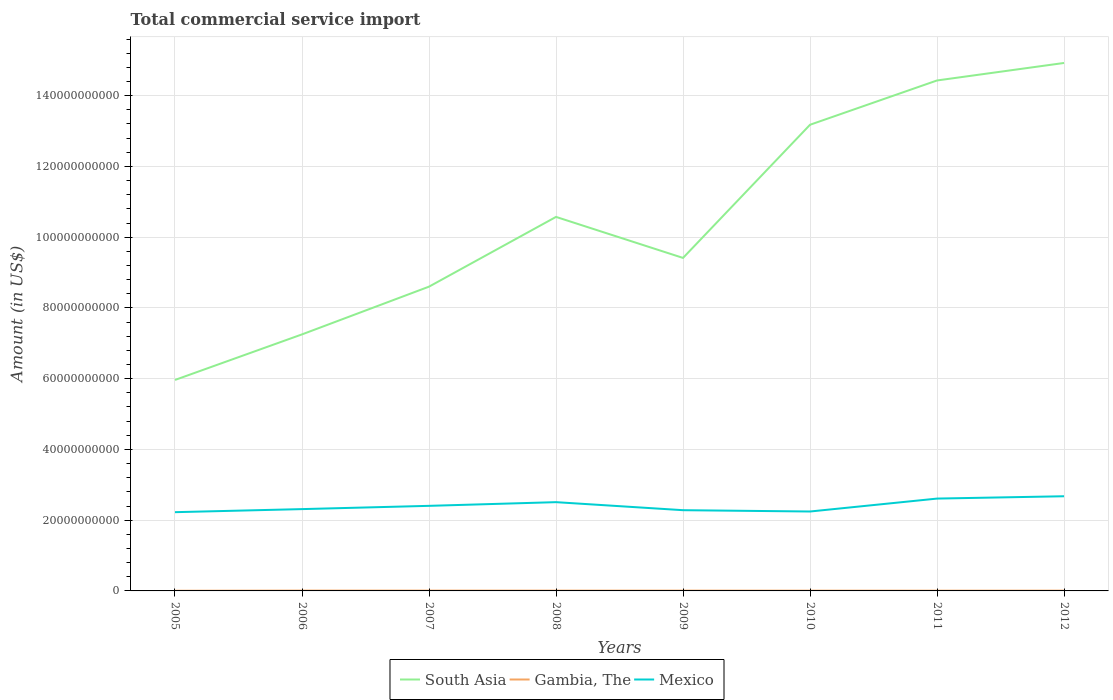Does the line corresponding to Gambia, The intersect with the line corresponding to South Asia?
Your response must be concise. No. Is the number of lines equal to the number of legend labels?
Ensure brevity in your answer.  Yes. Across all years, what is the maximum total commercial service import in Mexico?
Your answer should be compact. 2.23e+1. In which year was the total commercial service import in South Asia maximum?
Keep it short and to the point. 2005. What is the total total commercial service import in Gambia, The in the graph?
Provide a succinct answer. 4.19e+06. What is the difference between the highest and the second highest total commercial service import in Gambia, The?
Make the answer very short. 4.72e+07. What is the difference between the highest and the lowest total commercial service import in Mexico?
Keep it short and to the point. 3. Is the total commercial service import in Mexico strictly greater than the total commercial service import in South Asia over the years?
Your answer should be compact. Yes. How many years are there in the graph?
Your response must be concise. 8. What is the difference between two consecutive major ticks on the Y-axis?
Provide a short and direct response. 2.00e+1. Are the values on the major ticks of Y-axis written in scientific E-notation?
Offer a terse response. No. Where does the legend appear in the graph?
Provide a short and direct response. Bottom center. How are the legend labels stacked?
Keep it short and to the point. Horizontal. What is the title of the graph?
Your answer should be very brief. Total commercial service import. What is the label or title of the Y-axis?
Your response must be concise. Amount (in US$). What is the Amount (in US$) of South Asia in 2005?
Make the answer very short. 5.96e+1. What is the Amount (in US$) of Gambia, The in 2005?
Your answer should be compact. 4.69e+07. What is the Amount (in US$) of Mexico in 2005?
Make the answer very short. 2.23e+1. What is the Amount (in US$) of South Asia in 2006?
Provide a succinct answer. 7.25e+1. What is the Amount (in US$) of Gambia, The in 2006?
Your answer should be very brief. 9.41e+07. What is the Amount (in US$) in Mexico in 2006?
Provide a short and direct response. 2.31e+1. What is the Amount (in US$) in South Asia in 2007?
Ensure brevity in your answer.  8.60e+1. What is the Amount (in US$) of Gambia, The in 2007?
Provide a succinct answer. 8.68e+07. What is the Amount (in US$) of Mexico in 2007?
Ensure brevity in your answer.  2.41e+1. What is the Amount (in US$) of South Asia in 2008?
Your answer should be very brief. 1.06e+11. What is the Amount (in US$) in Gambia, The in 2008?
Your response must be concise. 8.56e+07. What is the Amount (in US$) of Mexico in 2008?
Offer a very short reply. 2.51e+1. What is the Amount (in US$) in South Asia in 2009?
Offer a terse response. 9.41e+1. What is the Amount (in US$) in Gambia, The in 2009?
Your response must be concise. 8.26e+07. What is the Amount (in US$) of Mexico in 2009?
Your response must be concise. 2.28e+1. What is the Amount (in US$) in South Asia in 2010?
Your answer should be compact. 1.32e+11. What is the Amount (in US$) of Gambia, The in 2010?
Keep it short and to the point. 7.32e+07. What is the Amount (in US$) of Mexico in 2010?
Offer a terse response. 2.25e+1. What is the Amount (in US$) of South Asia in 2011?
Provide a short and direct response. 1.44e+11. What is the Amount (in US$) in Gambia, The in 2011?
Keep it short and to the point. 6.84e+07. What is the Amount (in US$) in Mexico in 2011?
Offer a very short reply. 2.61e+1. What is the Amount (in US$) of South Asia in 2012?
Your response must be concise. 1.49e+11. What is the Amount (in US$) in Gambia, The in 2012?
Provide a succinct answer. 8.03e+07. What is the Amount (in US$) in Mexico in 2012?
Offer a very short reply. 2.68e+1. Across all years, what is the maximum Amount (in US$) of South Asia?
Provide a succinct answer. 1.49e+11. Across all years, what is the maximum Amount (in US$) in Gambia, The?
Your answer should be compact. 9.41e+07. Across all years, what is the maximum Amount (in US$) of Mexico?
Give a very brief answer. 2.68e+1. Across all years, what is the minimum Amount (in US$) of South Asia?
Provide a short and direct response. 5.96e+1. Across all years, what is the minimum Amount (in US$) of Gambia, The?
Ensure brevity in your answer.  4.69e+07. Across all years, what is the minimum Amount (in US$) in Mexico?
Keep it short and to the point. 2.23e+1. What is the total Amount (in US$) of South Asia in the graph?
Your answer should be compact. 8.43e+11. What is the total Amount (in US$) in Gambia, The in the graph?
Provide a short and direct response. 6.18e+08. What is the total Amount (in US$) of Mexico in the graph?
Make the answer very short. 1.93e+11. What is the difference between the Amount (in US$) in South Asia in 2005 and that in 2006?
Offer a very short reply. -1.29e+1. What is the difference between the Amount (in US$) of Gambia, The in 2005 and that in 2006?
Keep it short and to the point. -4.72e+07. What is the difference between the Amount (in US$) of Mexico in 2005 and that in 2006?
Your answer should be very brief. -8.67e+08. What is the difference between the Amount (in US$) of South Asia in 2005 and that in 2007?
Your response must be concise. -2.64e+1. What is the difference between the Amount (in US$) in Gambia, The in 2005 and that in 2007?
Offer a very short reply. -3.99e+07. What is the difference between the Amount (in US$) in Mexico in 2005 and that in 2007?
Your answer should be very brief. -1.79e+09. What is the difference between the Amount (in US$) in South Asia in 2005 and that in 2008?
Make the answer very short. -4.61e+1. What is the difference between the Amount (in US$) in Gambia, The in 2005 and that in 2008?
Give a very brief answer. -3.88e+07. What is the difference between the Amount (in US$) in Mexico in 2005 and that in 2008?
Provide a short and direct response. -2.83e+09. What is the difference between the Amount (in US$) in South Asia in 2005 and that in 2009?
Offer a terse response. -3.45e+1. What is the difference between the Amount (in US$) in Gambia, The in 2005 and that in 2009?
Your response must be concise. -3.57e+07. What is the difference between the Amount (in US$) in Mexico in 2005 and that in 2009?
Your answer should be compact. -5.61e+08. What is the difference between the Amount (in US$) of South Asia in 2005 and that in 2010?
Your answer should be very brief. -7.21e+1. What is the difference between the Amount (in US$) of Gambia, The in 2005 and that in 2010?
Make the answer very short. -2.63e+07. What is the difference between the Amount (in US$) in Mexico in 2005 and that in 2010?
Keep it short and to the point. -1.89e+08. What is the difference between the Amount (in US$) in South Asia in 2005 and that in 2011?
Give a very brief answer. -8.47e+1. What is the difference between the Amount (in US$) in Gambia, The in 2005 and that in 2011?
Your response must be concise. -2.15e+07. What is the difference between the Amount (in US$) of Mexico in 2005 and that in 2011?
Offer a very short reply. -3.84e+09. What is the difference between the Amount (in US$) in South Asia in 2005 and that in 2012?
Keep it short and to the point. -8.96e+1. What is the difference between the Amount (in US$) in Gambia, The in 2005 and that in 2012?
Make the answer very short. -3.34e+07. What is the difference between the Amount (in US$) in Mexico in 2005 and that in 2012?
Your answer should be very brief. -4.50e+09. What is the difference between the Amount (in US$) in South Asia in 2006 and that in 2007?
Make the answer very short. -1.35e+1. What is the difference between the Amount (in US$) in Gambia, The in 2006 and that in 2007?
Ensure brevity in your answer.  7.33e+06. What is the difference between the Amount (in US$) of Mexico in 2006 and that in 2007?
Your answer should be compact. -9.23e+08. What is the difference between the Amount (in US$) of South Asia in 2006 and that in 2008?
Make the answer very short. -3.32e+1. What is the difference between the Amount (in US$) of Gambia, The in 2006 and that in 2008?
Provide a succinct answer. 8.43e+06. What is the difference between the Amount (in US$) of Mexico in 2006 and that in 2008?
Keep it short and to the point. -1.96e+09. What is the difference between the Amount (in US$) in South Asia in 2006 and that in 2009?
Make the answer very short. -2.16e+1. What is the difference between the Amount (in US$) in Gambia, The in 2006 and that in 2009?
Your answer should be very brief. 1.15e+07. What is the difference between the Amount (in US$) in Mexico in 2006 and that in 2009?
Make the answer very short. 3.06e+08. What is the difference between the Amount (in US$) in South Asia in 2006 and that in 2010?
Ensure brevity in your answer.  -5.93e+1. What is the difference between the Amount (in US$) in Gambia, The in 2006 and that in 2010?
Keep it short and to the point. 2.09e+07. What is the difference between the Amount (in US$) in Mexico in 2006 and that in 2010?
Make the answer very short. 6.78e+08. What is the difference between the Amount (in US$) of South Asia in 2006 and that in 2011?
Keep it short and to the point. -7.18e+1. What is the difference between the Amount (in US$) in Gambia, The in 2006 and that in 2011?
Give a very brief answer. 2.57e+07. What is the difference between the Amount (in US$) in Mexico in 2006 and that in 2011?
Offer a very short reply. -2.98e+09. What is the difference between the Amount (in US$) of South Asia in 2006 and that in 2012?
Your answer should be very brief. -7.67e+1. What is the difference between the Amount (in US$) of Gambia, The in 2006 and that in 2012?
Give a very brief answer. 1.38e+07. What is the difference between the Amount (in US$) in Mexico in 2006 and that in 2012?
Ensure brevity in your answer.  -3.63e+09. What is the difference between the Amount (in US$) in South Asia in 2007 and that in 2008?
Your response must be concise. -1.97e+1. What is the difference between the Amount (in US$) in Gambia, The in 2007 and that in 2008?
Make the answer very short. 1.10e+06. What is the difference between the Amount (in US$) of Mexico in 2007 and that in 2008?
Make the answer very short. -1.04e+09. What is the difference between the Amount (in US$) in South Asia in 2007 and that in 2009?
Your answer should be compact. -8.12e+09. What is the difference between the Amount (in US$) of Gambia, The in 2007 and that in 2009?
Keep it short and to the point. 4.19e+06. What is the difference between the Amount (in US$) of Mexico in 2007 and that in 2009?
Give a very brief answer. 1.23e+09. What is the difference between the Amount (in US$) in South Asia in 2007 and that in 2010?
Offer a very short reply. -4.58e+1. What is the difference between the Amount (in US$) of Gambia, The in 2007 and that in 2010?
Your response must be concise. 1.36e+07. What is the difference between the Amount (in US$) in Mexico in 2007 and that in 2010?
Keep it short and to the point. 1.60e+09. What is the difference between the Amount (in US$) of South Asia in 2007 and that in 2011?
Your answer should be very brief. -5.83e+1. What is the difference between the Amount (in US$) in Gambia, The in 2007 and that in 2011?
Make the answer very short. 1.83e+07. What is the difference between the Amount (in US$) in Mexico in 2007 and that in 2011?
Your answer should be very brief. -2.05e+09. What is the difference between the Amount (in US$) in South Asia in 2007 and that in 2012?
Offer a terse response. -6.32e+1. What is the difference between the Amount (in US$) of Gambia, The in 2007 and that in 2012?
Offer a very short reply. 6.48e+06. What is the difference between the Amount (in US$) of Mexico in 2007 and that in 2012?
Offer a very short reply. -2.71e+09. What is the difference between the Amount (in US$) in South Asia in 2008 and that in 2009?
Keep it short and to the point. 1.16e+1. What is the difference between the Amount (in US$) in Gambia, The in 2008 and that in 2009?
Keep it short and to the point. 3.08e+06. What is the difference between the Amount (in US$) in Mexico in 2008 and that in 2009?
Provide a succinct answer. 2.27e+09. What is the difference between the Amount (in US$) in South Asia in 2008 and that in 2010?
Your answer should be compact. -2.61e+1. What is the difference between the Amount (in US$) of Gambia, The in 2008 and that in 2010?
Ensure brevity in your answer.  1.25e+07. What is the difference between the Amount (in US$) in Mexico in 2008 and that in 2010?
Give a very brief answer. 2.64e+09. What is the difference between the Amount (in US$) of South Asia in 2008 and that in 2011?
Your answer should be very brief. -3.86e+1. What is the difference between the Amount (in US$) in Gambia, The in 2008 and that in 2011?
Give a very brief answer. 1.72e+07. What is the difference between the Amount (in US$) of Mexico in 2008 and that in 2011?
Provide a short and direct response. -1.01e+09. What is the difference between the Amount (in US$) of South Asia in 2008 and that in 2012?
Offer a very short reply. -4.35e+1. What is the difference between the Amount (in US$) of Gambia, The in 2008 and that in 2012?
Provide a succinct answer. 5.38e+06. What is the difference between the Amount (in US$) in Mexico in 2008 and that in 2012?
Give a very brief answer. -1.67e+09. What is the difference between the Amount (in US$) of South Asia in 2009 and that in 2010?
Provide a short and direct response. -3.76e+1. What is the difference between the Amount (in US$) in Gambia, The in 2009 and that in 2010?
Provide a succinct answer. 9.39e+06. What is the difference between the Amount (in US$) in Mexico in 2009 and that in 2010?
Offer a very short reply. 3.72e+08. What is the difference between the Amount (in US$) of South Asia in 2009 and that in 2011?
Provide a short and direct response. -5.02e+1. What is the difference between the Amount (in US$) of Gambia, The in 2009 and that in 2011?
Provide a succinct answer. 1.42e+07. What is the difference between the Amount (in US$) in Mexico in 2009 and that in 2011?
Make the answer very short. -3.28e+09. What is the difference between the Amount (in US$) of South Asia in 2009 and that in 2012?
Offer a very short reply. -5.51e+1. What is the difference between the Amount (in US$) of Gambia, The in 2009 and that in 2012?
Offer a very short reply. 2.30e+06. What is the difference between the Amount (in US$) in Mexico in 2009 and that in 2012?
Keep it short and to the point. -3.94e+09. What is the difference between the Amount (in US$) of South Asia in 2010 and that in 2011?
Keep it short and to the point. -1.25e+1. What is the difference between the Amount (in US$) of Gambia, The in 2010 and that in 2011?
Give a very brief answer. 4.77e+06. What is the difference between the Amount (in US$) in Mexico in 2010 and that in 2011?
Ensure brevity in your answer.  -3.65e+09. What is the difference between the Amount (in US$) of South Asia in 2010 and that in 2012?
Provide a succinct answer. -1.75e+1. What is the difference between the Amount (in US$) of Gambia, The in 2010 and that in 2012?
Your response must be concise. -7.09e+06. What is the difference between the Amount (in US$) of Mexico in 2010 and that in 2012?
Offer a terse response. -4.31e+09. What is the difference between the Amount (in US$) of South Asia in 2011 and that in 2012?
Your response must be concise. -4.95e+09. What is the difference between the Amount (in US$) of Gambia, The in 2011 and that in 2012?
Offer a very short reply. -1.19e+07. What is the difference between the Amount (in US$) in Mexico in 2011 and that in 2012?
Give a very brief answer. -6.57e+08. What is the difference between the Amount (in US$) of South Asia in 2005 and the Amount (in US$) of Gambia, The in 2006?
Offer a terse response. 5.95e+1. What is the difference between the Amount (in US$) in South Asia in 2005 and the Amount (in US$) in Mexico in 2006?
Provide a succinct answer. 3.65e+1. What is the difference between the Amount (in US$) in Gambia, The in 2005 and the Amount (in US$) in Mexico in 2006?
Give a very brief answer. -2.31e+1. What is the difference between the Amount (in US$) of South Asia in 2005 and the Amount (in US$) of Gambia, The in 2007?
Your answer should be compact. 5.96e+1. What is the difference between the Amount (in US$) in South Asia in 2005 and the Amount (in US$) in Mexico in 2007?
Keep it short and to the point. 3.56e+1. What is the difference between the Amount (in US$) in Gambia, The in 2005 and the Amount (in US$) in Mexico in 2007?
Your response must be concise. -2.40e+1. What is the difference between the Amount (in US$) in South Asia in 2005 and the Amount (in US$) in Gambia, The in 2008?
Offer a very short reply. 5.96e+1. What is the difference between the Amount (in US$) in South Asia in 2005 and the Amount (in US$) in Mexico in 2008?
Make the answer very short. 3.45e+1. What is the difference between the Amount (in US$) of Gambia, The in 2005 and the Amount (in US$) of Mexico in 2008?
Your response must be concise. -2.50e+1. What is the difference between the Amount (in US$) in South Asia in 2005 and the Amount (in US$) in Gambia, The in 2009?
Offer a very short reply. 5.96e+1. What is the difference between the Amount (in US$) in South Asia in 2005 and the Amount (in US$) in Mexico in 2009?
Your answer should be compact. 3.68e+1. What is the difference between the Amount (in US$) of Gambia, The in 2005 and the Amount (in US$) of Mexico in 2009?
Give a very brief answer. -2.28e+1. What is the difference between the Amount (in US$) in South Asia in 2005 and the Amount (in US$) in Gambia, The in 2010?
Offer a terse response. 5.96e+1. What is the difference between the Amount (in US$) in South Asia in 2005 and the Amount (in US$) in Mexico in 2010?
Offer a very short reply. 3.72e+1. What is the difference between the Amount (in US$) in Gambia, The in 2005 and the Amount (in US$) in Mexico in 2010?
Keep it short and to the point. -2.24e+1. What is the difference between the Amount (in US$) of South Asia in 2005 and the Amount (in US$) of Gambia, The in 2011?
Offer a very short reply. 5.96e+1. What is the difference between the Amount (in US$) of South Asia in 2005 and the Amount (in US$) of Mexico in 2011?
Provide a short and direct response. 3.35e+1. What is the difference between the Amount (in US$) in Gambia, The in 2005 and the Amount (in US$) in Mexico in 2011?
Offer a very short reply. -2.61e+1. What is the difference between the Amount (in US$) of South Asia in 2005 and the Amount (in US$) of Gambia, The in 2012?
Your answer should be compact. 5.96e+1. What is the difference between the Amount (in US$) in South Asia in 2005 and the Amount (in US$) in Mexico in 2012?
Provide a short and direct response. 3.29e+1. What is the difference between the Amount (in US$) of Gambia, The in 2005 and the Amount (in US$) of Mexico in 2012?
Provide a short and direct response. -2.67e+1. What is the difference between the Amount (in US$) of South Asia in 2006 and the Amount (in US$) of Gambia, The in 2007?
Your answer should be compact. 7.24e+1. What is the difference between the Amount (in US$) of South Asia in 2006 and the Amount (in US$) of Mexico in 2007?
Give a very brief answer. 4.85e+1. What is the difference between the Amount (in US$) in Gambia, The in 2006 and the Amount (in US$) in Mexico in 2007?
Ensure brevity in your answer.  -2.40e+1. What is the difference between the Amount (in US$) of South Asia in 2006 and the Amount (in US$) of Gambia, The in 2008?
Provide a short and direct response. 7.24e+1. What is the difference between the Amount (in US$) of South Asia in 2006 and the Amount (in US$) of Mexico in 2008?
Offer a terse response. 4.74e+1. What is the difference between the Amount (in US$) of Gambia, The in 2006 and the Amount (in US$) of Mexico in 2008?
Provide a succinct answer. -2.50e+1. What is the difference between the Amount (in US$) of South Asia in 2006 and the Amount (in US$) of Gambia, The in 2009?
Make the answer very short. 7.24e+1. What is the difference between the Amount (in US$) in South Asia in 2006 and the Amount (in US$) in Mexico in 2009?
Provide a short and direct response. 4.97e+1. What is the difference between the Amount (in US$) in Gambia, The in 2006 and the Amount (in US$) in Mexico in 2009?
Offer a very short reply. -2.27e+1. What is the difference between the Amount (in US$) of South Asia in 2006 and the Amount (in US$) of Gambia, The in 2010?
Provide a succinct answer. 7.24e+1. What is the difference between the Amount (in US$) in South Asia in 2006 and the Amount (in US$) in Mexico in 2010?
Your response must be concise. 5.01e+1. What is the difference between the Amount (in US$) in Gambia, The in 2006 and the Amount (in US$) in Mexico in 2010?
Offer a terse response. -2.24e+1. What is the difference between the Amount (in US$) in South Asia in 2006 and the Amount (in US$) in Gambia, The in 2011?
Your answer should be compact. 7.24e+1. What is the difference between the Amount (in US$) of South Asia in 2006 and the Amount (in US$) of Mexico in 2011?
Your answer should be compact. 4.64e+1. What is the difference between the Amount (in US$) of Gambia, The in 2006 and the Amount (in US$) of Mexico in 2011?
Provide a short and direct response. -2.60e+1. What is the difference between the Amount (in US$) in South Asia in 2006 and the Amount (in US$) in Gambia, The in 2012?
Keep it short and to the point. 7.24e+1. What is the difference between the Amount (in US$) in South Asia in 2006 and the Amount (in US$) in Mexico in 2012?
Your response must be concise. 4.58e+1. What is the difference between the Amount (in US$) of Gambia, The in 2006 and the Amount (in US$) of Mexico in 2012?
Provide a succinct answer. -2.67e+1. What is the difference between the Amount (in US$) of South Asia in 2007 and the Amount (in US$) of Gambia, The in 2008?
Your answer should be compact. 8.59e+1. What is the difference between the Amount (in US$) of South Asia in 2007 and the Amount (in US$) of Mexico in 2008?
Your answer should be very brief. 6.09e+1. What is the difference between the Amount (in US$) of Gambia, The in 2007 and the Amount (in US$) of Mexico in 2008?
Ensure brevity in your answer.  -2.50e+1. What is the difference between the Amount (in US$) of South Asia in 2007 and the Amount (in US$) of Gambia, The in 2009?
Make the answer very short. 8.59e+1. What is the difference between the Amount (in US$) in South Asia in 2007 and the Amount (in US$) in Mexico in 2009?
Your answer should be very brief. 6.32e+1. What is the difference between the Amount (in US$) in Gambia, The in 2007 and the Amount (in US$) in Mexico in 2009?
Make the answer very short. -2.27e+1. What is the difference between the Amount (in US$) in South Asia in 2007 and the Amount (in US$) in Gambia, The in 2010?
Ensure brevity in your answer.  8.59e+1. What is the difference between the Amount (in US$) of South Asia in 2007 and the Amount (in US$) of Mexico in 2010?
Give a very brief answer. 6.36e+1. What is the difference between the Amount (in US$) in Gambia, The in 2007 and the Amount (in US$) in Mexico in 2010?
Your response must be concise. -2.24e+1. What is the difference between the Amount (in US$) of South Asia in 2007 and the Amount (in US$) of Gambia, The in 2011?
Your answer should be compact. 8.59e+1. What is the difference between the Amount (in US$) in South Asia in 2007 and the Amount (in US$) in Mexico in 2011?
Provide a short and direct response. 5.99e+1. What is the difference between the Amount (in US$) of Gambia, The in 2007 and the Amount (in US$) of Mexico in 2011?
Your answer should be compact. -2.60e+1. What is the difference between the Amount (in US$) of South Asia in 2007 and the Amount (in US$) of Gambia, The in 2012?
Your answer should be very brief. 8.59e+1. What is the difference between the Amount (in US$) in South Asia in 2007 and the Amount (in US$) in Mexico in 2012?
Offer a terse response. 5.93e+1. What is the difference between the Amount (in US$) in Gambia, The in 2007 and the Amount (in US$) in Mexico in 2012?
Your response must be concise. -2.67e+1. What is the difference between the Amount (in US$) of South Asia in 2008 and the Amount (in US$) of Gambia, The in 2009?
Your answer should be very brief. 1.06e+11. What is the difference between the Amount (in US$) in South Asia in 2008 and the Amount (in US$) in Mexico in 2009?
Make the answer very short. 8.29e+1. What is the difference between the Amount (in US$) in Gambia, The in 2008 and the Amount (in US$) in Mexico in 2009?
Offer a very short reply. -2.27e+1. What is the difference between the Amount (in US$) of South Asia in 2008 and the Amount (in US$) of Gambia, The in 2010?
Make the answer very short. 1.06e+11. What is the difference between the Amount (in US$) in South Asia in 2008 and the Amount (in US$) in Mexico in 2010?
Offer a terse response. 8.33e+1. What is the difference between the Amount (in US$) of Gambia, The in 2008 and the Amount (in US$) of Mexico in 2010?
Offer a very short reply. -2.24e+1. What is the difference between the Amount (in US$) in South Asia in 2008 and the Amount (in US$) in Gambia, The in 2011?
Your answer should be very brief. 1.06e+11. What is the difference between the Amount (in US$) in South Asia in 2008 and the Amount (in US$) in Mexico in 2011?
Provide a short and direct response. 7.96e+1. What is the difference between the Amount (in US$) of Gambia, The in 2008 and the Amount (in US$) of Mexico in 2011?
Ensure brevity in your answer.  -2.60e+1. What is the difference between the Amount (in US$) in South Asia in 2008 and the Amount (in US$) in Gambia, The in 2012?
Your answer should be very brief. 1.06e+11. What is the difference between the Amount (in US$) of South Asia in 2008 and the Amount (in US$) of Mexico in 2012?
Your response must be concise. 7.90e+1. What is the difference between the Amount (in US$) of Gambia, The in 2008 and the Amount (in US$) of Mexico in 2012?
Your answer should be very brief. -2.67e+1. What is the difference between the Amount (in US$) in South Asia in 2009 and the Amount (in US$) in Gambia, The in 2010?
Give a very brief answer. 9.41e+1. What is the difference between the Amount (in US$) in South Asia in 2009 and the Amount (in US$) in Mexico in 2010?
Offer a terse response. 7.17e+1. What is the difference between the Amount (in US$) in Gambia, The in 2009 and the Amount (in US$) in Mexico in 2010?
Offer a very short reply. -2.24e+1. What is the difference between the Amount (in US$) of South Asia in 2009 and the Amount (in US$) of Gambia, The in 2011?
Offer a very short reply. 9.41e+1. What is the difference between the Amount (in US$) of South Asia in 2009 and the Amount (in US$) of Mexico in 2011?
Ensure brevity in your answer.  6.80e+1. What is the difference between the Amount (in US$) in Gambia, The in 2009 and the Amount (in US$) in Mexico in 2011?
Offer a very short reply. -2.60e+1. What is the difference between the Amount (in US$) in South Asia in 2009 and the Amount (in US$) in Gambia, The in 2012?
Your response must be concise. 9.41e+1. What is the difference between the Amount (in US$) in South Asia in 2009 and the Amount (in US$) in Mexico in 2012?
Your response must be concise. 6.74e+1. What is the difference between the Amount (in US$) in Gambia, The in 2009 and the Amount (in US$) in Mexico in 2012?
Ensure brevity in your answer.  -2.67e+1. What is the difference between the Amount (in US$) of South Asia in 2010 and the Amount (in US$) of Gambia, The in 2011?
Ensure brevity in your answer.  1.32e+11. What is the difference between the Amount (in US$) in South Asia in 2010 and the Amount (in US$) in Mexico in 2011?
Your response must be concise. 1.06e+11. What is the difference between the Amount (in US$) of Gambia, The in 2010 and the Amount (in US$) of Mexico in 2011?
Offer a terse response. -2.60e+1. What is the difference between the Amount (in US$) in South Asia in 2010 and the Amount (in US$) in Gambia, The in 2012?
Ensure brevity in your answer.  1.32e+11. What is the difference between the Amount (in US$) of South Asia in 2010 and the Amount (in US$) of Mexico in 2012?
Make the answer very short. 1.05e+11. What is the difference between the Amount (in US$) of Gambia, The in 2010 and the Amount (in US$) of Mexico in 2012?
Make the answer very short. -2.67e+1. What is the difference between the Amount (in US$) in South Asia in 2011 and the Amount (in US$) in Gambia, The in 2012?
Your response must be concise. 1.44e+11. What is the difference between the Amount (in US$) in South Asia in 2011 and the Amount (in US$) in Mexico in 2012?
Make the answer very short. 1.18e+11. What is the difference between the Amount (in US$) of Gambia, The in 2011 and the Amount (in US$) of Mexico in 2012?
Offer a very short reply. -2.67e+1. What is the average Amount (in US$) of South Asia per year?
Keep it short and to the point. 1.05e+11. What is the average Amount (in US$) of Gambia, The per year?
Your answer should be very brief. 7.72e+07. What is the average Amount (in US$) of Mexico per year?
Your answer should be very brief. 2.41e+1. In the year 2005, what is the difference between the Amount (in US$) of South Asia and Amount (in US$) of Gambia, The?
Ensure brevity in your answer.  5.96e+1. In the year 2005, what is the difference between the Amount (in US$) in South Asia and Amount (in US$) in Mexico?
Provide a succinct answer. 3.74e+1. In the year 2005, what is the difference between the Amount (in US$) in Gambia, The and Amount (in US$) in Mexico?
Give a very brief answer. -2.22e+1. In the year 2006, what is the difference between the Amount (in US$) in South Asia and Amount (in US$) in Gambia, The?
Ensure brevity in your answer.  7.24e+1. In the year 2006, what is the difference between the Amount (in US$) of South Asia and Amount (in US$) of Mexico?
Provide a short and direct response. 4.94e+1. In the year 2006, what is the difference between the Amount (in US$) of Gambia, The and Amount (in US$) of Mexico?
Provide a short and direct response. -2.30e+1. In the year 2007, what is the difference between the Amount (in US$) of South Asia and Amount (in US$) of Gambia, The?
Provide a short and direct response. 8.59e+1. In the year 2007, what is the difference between the Amount (in US$) in South Asia and Amount (in US$) in Mexico?
Provide a succinct answer. 6.20e+1. In the year 2007, what is the difference between the Amount (in US$) of Gambia, The and Amount (in US$) of Mexico?
Provide a succinct answer. -2.40e+1. In the year 2008, what is the difference between the Amount (in US$) in South Asia and Amount (in US$) in Gambia, The?
Your answer should be compact. 1.06e+11. In the year 2008, what is the difference between the Amount (in US$) in South Asia and Amount (in US$) in Mexico?
Your answer should be compact. 8.06e+1. In the year 2008, what is the difference between the Amount (in US$) in Gambia, The and Amount (in US$) in Mexico?
Offer a terse response. -2.50e+1. In the year 2009, what is the difference between the Amount (in US$) in South Asia and Amount (in US$) in Gambia, The?
Provide a short and direct response. 9.41e+1. In the year 2009, what is the difference between the Amount (in US$) in South Asia and Amount (in US$) in Mexico?
Provide a short and direct response. 7.13e+1. In the year 2009, what is the difference between the Amount (in US$) of Gambia, The and Amount (in US$) of Mexico?
Give a very brief answer. -2.27e+1. In the year 2010, what is the difference between the Amount (in US$) of South Asia and Amount (in US$) of Gambia, The?
Make the answer very short. 1.32e+11. In the year 2010, what is the difference between the Amount (in US$) of South Asia and Amount (in US$) of Mexico?
Your answer should be very brief. 1.09e+11. In the year 2010, what is the difference between the Amount (in US$) of Gambia, The and Amount (in US$) of Mexico?
Give a very brief answer. -2.24e+1. In the year 2011, what is the difference between the Amount (in US$) in South Asia and Amount (in US$) in Gambia, The?
Your response must be concise. 1.44e+11. In the year 2011, what is the difference between the Amount (in US$) of South Asia and Amount (in US$) of Mexico?
Offer a terse response. 1.18e+11. In the year 2011, what is the difference between the Amount (in US$) in Gambia, The and Amount (in US$) in Mexico?
Provide a succinct answer. -2.60e+1. In the year 2012, what is the difference between the Amount (in US$) in South Asia and Amount (in US$) in Gambia, The?
Keep it short and to the point. 1.49e+11. In the year 2012, what is the difference between the Amount (in US$) of South Asia and Amount (in US$) of Mexico?
Offer a terse response. 1.22e+11. In the year 2012, what is the difference between the Amount (in US$) of Gambia, The and Amount (in US$) of Mexico?
Make the answer very short. -2.67e+1. What is the ratio of the Amount (in US$) in South Asia in 2005 to that in 2006?
Make the answer very short. 0.82. What is the ratio of the Amount (in US$) in Gambia, The in 2005 to that in 2006?
Give a very brief answer. 0.5. What is the ratio of the Amount (in US$) of Mexico in 2005 to that in 2006?
Your answer should be compact. 0.96. What is the ratio of the Amount (in US$) of South Asia in 2005 to that in 2007?
Provide a short and direct response. 0.69. What is the ratio of the Amount (in US$) in Gambia, The in 2005 to that in 2007?
Provide a succinct answer. 0.54. What is the ratio of the Amount (in US$) of Mexico in 2005 to that in 2007?
Offer a terse response. 0.93. What is the ratio of the Amount (in US$) in South Asia in 2005 to that in 2008?
Offer a very short reply. 0.56. What is the ratio of the Amount (in US$) of Gambia, The in 2005 to that in 2008?
Offer a very short reply. 0.55. What is the ratio of the Amount (in US$) in Mexico in 2005 to that in 2008?
Keep it short and to the point. 0.89. What is the ratio of the Amount (in US$) of South Asia in 2005 to that in 2009?
Offer a terse response. 0.63. What is the ratio of the Amount (in US$) in Gambia, The in 2005 to that in 2009?
Your response must be concise. 0.57. What is the ratio of the Amount (in US$) of Mexico in 2005 to that in 2009?
Your answer should be compact. 0.98. What is the ratio of the Amount (in US$) in South Asia in 2005 to that in 2010?
Provide a short and direct response. 0.45. What is the ratio of the Amount (in US$) in Gambia, The in 2005 to that in 2010?
Ensure brevity in your answer.  0.64. What is the ratio of the Amount (in US$) in South Asia in 2005 to that in 2011?
Keep it short and to the point. 0.41. What is the ratio of the Amount (in US$) of Gambia, The in 2005 to that in 2011?
Keep it short and to the point. 0.69. What is the ratio of the Amount (in US$) of Mexico in 2005 to that in 2011?
Your answer should be very brief. 0.85. What is the ratio of the Amount (in US$) in South Asia in 2005 to that in 2012?
Make the answer very short. 0.4. What is the ratio of the Amount (in US$) of Gambia, The in 2005 to that in 2012?
Your response must be concise. 0.58. What is the ratio of the Amount (in US$) of Mexico in 2005 to that in 2012?
Provide a succinct answer. 0.83. What is the ratio of the Amount (in US$) of South Asia in 2006 to that in 2007?
Your response must be concise. 0.84. What is the ratio of the Amount (in US$) in Gambia, The in 2006 to that in 2007?
Your answer should be very brief. 1.08. What is the ratio of the Amount (in US$) of Mexico in 2006 to that in 2007?
Your response must be concise. 0.96. What is the ratio of the Amount (in US$) of South Asia in 2006 to that in 2008?
Make the answer very short. 0.69. What is the ratio of the Amount (in US$) in Gambia, The in 2006 to that in 2008?
Give a very brief answer. 1.1. What is the ratio of the Amount (in US$) in Mexico in 2006 to that in 2008?
Keep it short and to the point. 0.92. What is the ratio of the Amount (in US$) in South Asia in 2006 to that in 2009?
Offer a very short reply. 0.77. What is the ratio of the Amount (in US$) in Gambia, The in 2006 to that in 2009?
Offer a very short reply. 1.14. What is the ratio of the Amount (in US$) in Mexico in 2006 to that in 2009?
Your answer should be very brief. 1.01. What is the ratio of the Amount (in US$) of South Asia in 2006 to that in 2010?
Your answer should be compact. 0.55. What is the ratio of the Amount (in US$) of Gambia, The in 2006 to that in 2010?
Your answer should be compact. 1.29. What is the ratio of the Amount (in US$) in Mexico in 2006 to that in 2010?
Provide a short and direct response. 1.03. What is the ratio of the Amount (in US$) of South Asia in 2006 to that in 2011?
Provide a succinct answer. 0.5. What is the ratio of the Amount (in US$) in Gambia, The in 2006 to that in 2011?
Ensure brevity in your answer.  1.38. What is the ratio of the Amount (in US$) of Mexico in 2006 to that in 2011?
Your answer should be very brief. 0.89. What is the ratio of the Amount (in US$) of South Asia in 2006 to that in 2012?
Provide a short and direct response. 0.49. What is the ratio of the Amount (in US$) of Gambia, The in 2006 to that in 2012?
Make the answer very short. 1.17. What is the ratio of the Amount (in US$) of Mexico in 2006 to that in 2012?
Offer a very short reply. 0.86. What is the ratio of the Amount (in US$) in South Asia in 2007 to that in 2008?
Provide a succinct answer. 0.81. What is the ratio of the Amount (in US$) of Gambia, The in 2007 to that in 2008?
Offer a very short reply. 1.01. What is the ratio of the Amount (in US$) in Mexico in 2007 to that in 2008?
Your answer should be compact. 0.96. What is the ratio of the Amount (in US$) of South Asia in 2007 to that in 2009?
Offer a very short reply. 0.91. What is the ratio of the Amount (in US$) of Gambia, The in 2007 to that in 2009?
Make the answer very short. 1.05. What is the ratio of the Amount (in US$) in Mexico in 2007 to that in 2009?
Your response must be concise. 1.05. What is the ratio of the Amount (in US$) of South Asia in 2007 to that in 2010?
Provide a short and direct response. 0.65. What is the ratio of the Amount (in US$) in Gambia, The in 2007 to that in 2010?
Offer a very short reply. 1.19. What is the ratio of the Amount (in US$) in Mexico in 2007 to that in 2010?
Provide a short and direct response. 1.07. What is the ratio of the Amount (in US$) of South Asia in 2007 to that in 2011?
Make the answer very short. 0.6. What is the ratio of the Amount (in US$) of Gambia, The in 2007 to that in 2011?
Provide a short and direct response. 1.27. What is the ratio of the Amount (in US$) in Mexico in 2007 to that in 2011?
Keep it short and to the point. 0.92. What is the ratio of the Amount (in US$) of South Asia in 2007 to that in 2012?
Offer a terse response. 0.58. What is the ratio of the Amount (in US$) of Gambia, The in 2007 to that in 2012?
Your answer should be compact. 1.08. What is the ratio of the Amount (in US$) of Mexico in 2007 to that in 2012?
Make the answer very short. 0.9. What is the ratio of the Amount (in US$) in South Asia in 2008 to that in 2009?
Offer a very short reply. 1.12. What is the ratio of the Amount (in US$) in Gambia, The in 2008 to that in 2009?
Make the answer very short. 1.04. What is the ratio of the Amount (in US$) of Mexico in 2008 to that in 2009?
Ensure brevity in your answer.  1.1. What is the ratio of the Amount (in US$) of South Asia in 2008 to that in 2010?
Give a very brief answer. 0.8. What is the ratio of the Amount (in US$) of Gambia, The in 2008 to that in 2010?
Give a very brief answer. 1.17. What is the ratio of the Amount (in US$) in Mexico in 2008 to that in 2010?
Your answer should be very brief. 1.12. What is the ratio of the Amount (in US$) in South Asia in 2008 to that in 2011?
Provide a succinct answer. 0.73. What is the ratio of the Amount (in US$) of Gambia, The in 2008 to that in 2011?
Offer a very short reply. 1.25. What is the ratio of the Amount (in US$) in Mexico in 2008 to that in 2011?
Offer a terse response. 0.96. What is the ratio of the Amount (in US$) of South Asia in 2008 to that in 2012?
Give a very brief answer. 0.71. What is the ratio of the Amount (in US$) in Gambia, The in 2008 to that in 2012?
Your answer should be compact. 1.07. What is the ratio of the Amount (in US$) in Mexico in 2008 to that in 2012?
Make the answer very short. 0.94. What is the ratio of the Amount (in US$) of Gambia, The in 2009 to that in 2010?
Your response must be concise. 1.13. What is the ratio of the Amount (in US$) in Mexico in 2009 to that in 2010?
Ensure brevity in your answer.  1.02. What is the ratio of the Amount (in US$) in South Asia in 2009 to that in 2011?
Your answer should be very brief. 0.65. What is the ratio of the Amount (in US$) of Gambia, The in 2009 to that in 2011?
Provide a succinct answer. 1.21. What is the ratio of the Amount (in US$) in Mexico in 2009 to that in 2011?
Offer a terse response. 0.87. What is the ratio of the Amount (in US$) in South Asia in 2009 to that in 2012?
Your answer should be very brief. 0.63. What is the ratio of the Amount (in US$) in Gambia, The in 2009 to that in 2012?
Provide a short and direct response. 1.03. What is the ratio of the Amount (in US$) of Mexico in 2009 to that in 2012?
Offer a terse response. 0.85. What is the ratio of the Amount (in US$) in South Asia in 2010 to that in 2011?
Your answer should be very brief. 0.91. What is the ratio of the Amount (in US$) in Gambia, The in 2010 to that in 2011?
Keep it short and to the point. 1.07. What is the ratio of the Amount (in US$) of Mexico in 2010 to that in 2011?
Your answer should be compact. 0.86. What is the ratio of the Amount (in US$) in South Asia in 2010 to that in 2012?
Your response must be concise. 0.88. What is the ratio of the Amount (in US$) in Gambia, The in 2010 to that in 2012?
Offer a terse response. 0.91. What is the ratio of the Amount (in US$) in Mexico in 2010 to that in 2012?
Offer a very short reply. 0.84. What is the ratio of the Amount (in US$) in South Asia in 2011 to that in 2012?
Offer a terse response. 0.97. What is the ratio of the Amount (in US$) of Gambia, The in 2011 to that in 2012?
Your answer should be very brief. 0.85. What is the ratio of the Amount (in US$) of Mexico in 2011 to that in 2012?
Offer a terse response. 0.98. What is the difference between the highest and the second highest Amount (in US$) of South Asia?
Make the answer very short. 4.95e+09. What is the difference between the highest and the second highest Amount (in US$) in Gambia, The?
Ensure brevity in your answer.  7.33e+06. What is the difference between the highest and the second highest Amount (in US$) in Mexico?
Offer a terse response. 6.57e+08. What is the difference between the highest and the lowest Amount (in US$) in South Asia?
Offer a very short reply. 8.96e+1. What is the difference between the highest and the lowest Amount (in US$) of Gambia, The?
Give a very brief answer. 4.72e+07. What is the difference between the highest and the lowest Amount (in US$) of Mexico?
Your answer should be compact. 4.50e+09. 